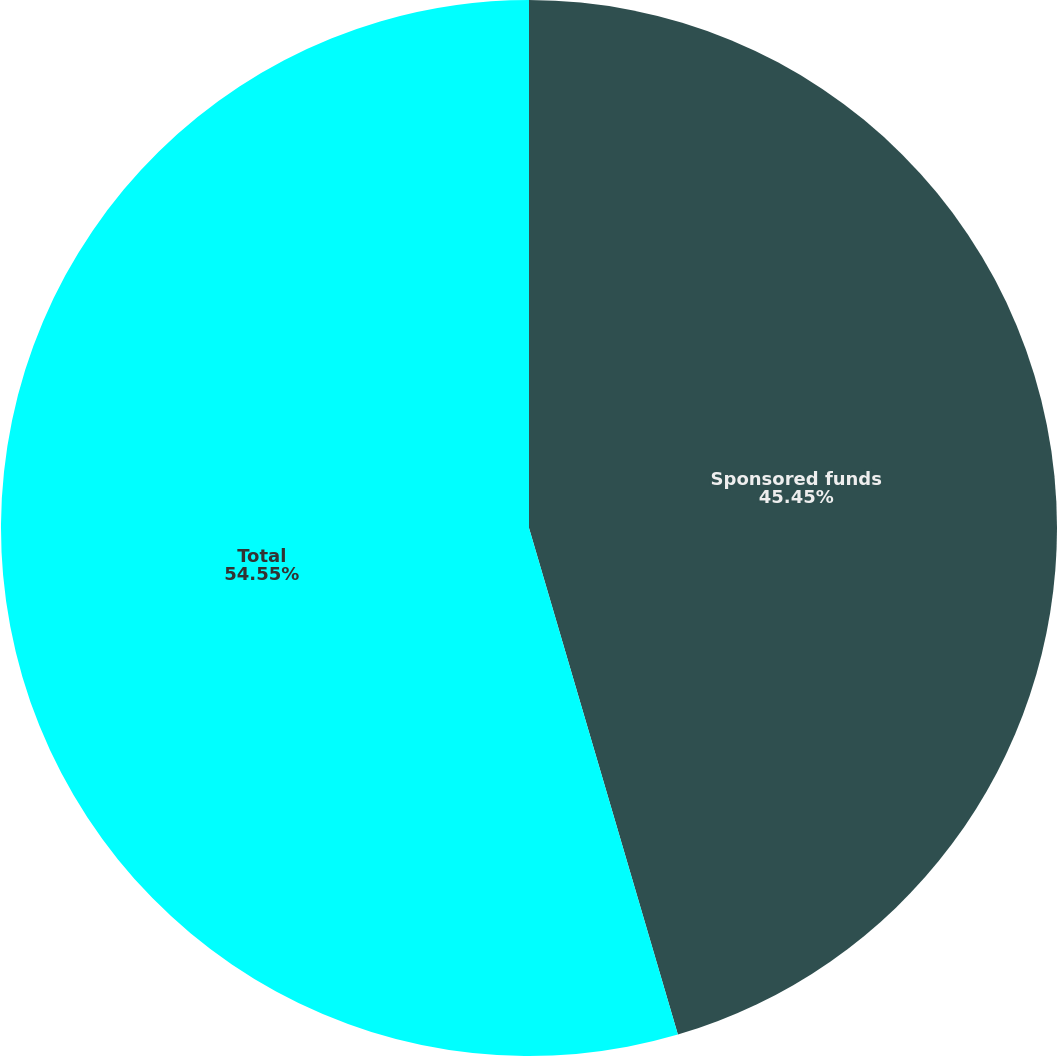Convert chart to OTSL. <chart><loc_0><loc_0><loc_500><loc_500><pie_chart><fcel>Sponsored funds<fcel>Total<nl><fcel>45.45%<fcel>54.55%<nl></chart> 